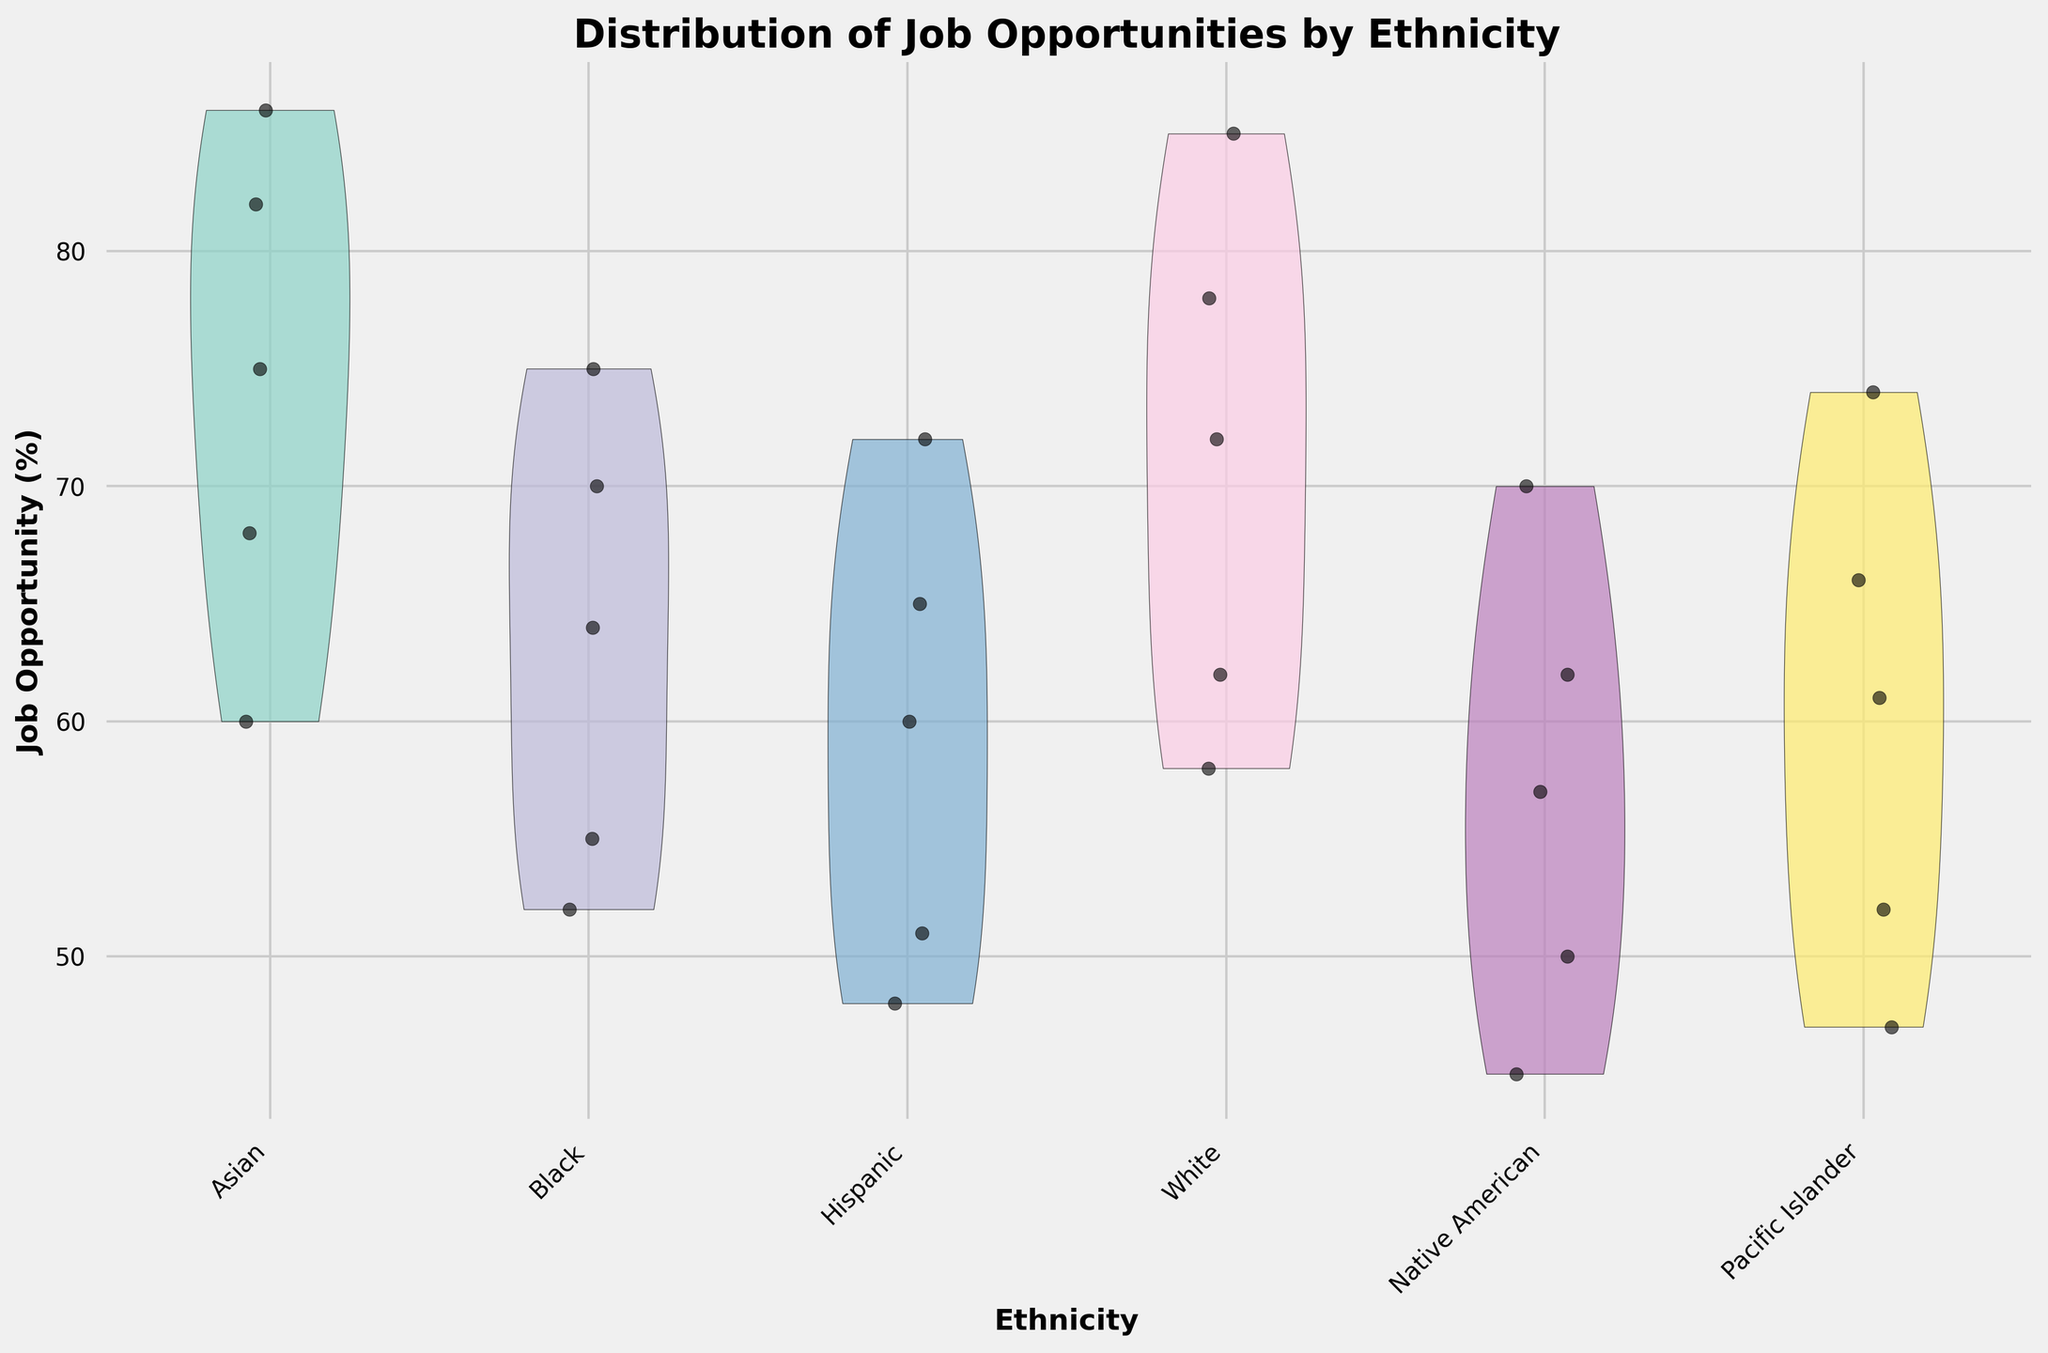What is the title of the figure? The title is usually located at the top of the figure and describes the main focus of the plot. In this case, it is "Distribution of Job Opportunities by Ethnicity".
Answer: Distribution of Job Opportunities by Ethnicity Which ethnicity shows the highest median job opportunity percentage? By observing the widest part of the violin plot for each ethnicity, we can see that the group with the highest median job opportunity percentage appears to be the Asian ethnicity.
Answer: Asian How many ethnicities are represented in the figure? Count the number of different categories on the x-axis, which represent distinct ethnic groups.
Answer: 6 Which ethnicity has the lowest high school diploma job opportunity percentage? Look for the data points (jittered points) in the "High School Diploma" category and find the minimum value. The lowest point for high school diploma is found in the Native American group.
Answer: Native American Compare the job opportunity range of Bachelor's degree holders between Black and White ethnic groups. To determine the range, observe the spread of the violin plot from the lowest to highest value for Bachelor's degree within the Black and White groups. White ethnicity appears to have a slightly higher overall range.
Answer: White has a wider range Which ethnic group shows the least variation in job opportunities for Doctorate degree holders? The variation is indicated by the width and spread of the violin plot. The narrower the plot, the less variation in job opportunities. Pacific Islander appears to have the least variation.
Answer: Pacific Islander What is the average job opportunity percentage for Associate Degree holders across all ethnicities? Calculate the mean of the job opportunity percentages for each ethnicity in the "Associate Degree" category (68+55+51+62+50+52)/6 = 56.33.
Answer: 56.33 Which ethnic group shows a higher job opportunity for Master's degree holders, Hispanic or Native American? Compare the medians in the violin plots for Master's degrees in Hispanic and Native American groups. Hispanic has a higher median job opportunity.
Answer: Hispanic Identify the ethnic group with the most consistent job opportunities across all educational attainments. Look for the ethnic group whose violin plots show the tightest distributions across all education levels. The Asian group appears to have the most consistent distribution.
Answer: Asian 